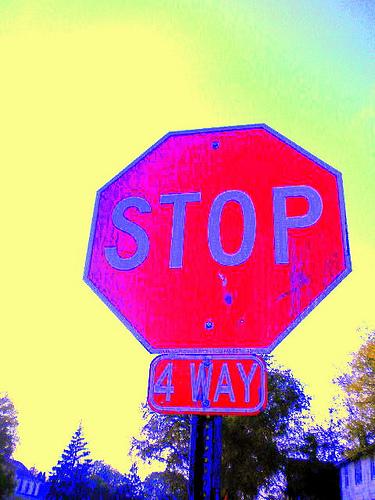What color is the sky?
Quick response, please. Yellow. Is this a 2 way stop?
Give a very brief answer. No. Are there trees visible?
Concise answer only. Yes. 